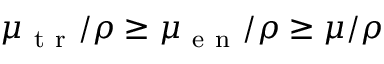Convert formula to latex. <formula><loc_0><loc_0><loc_500><loc_500>\mu _ { t r } / \rho \geq \mu _ { e n } / \rho \geq \mu / \rho</formula> 